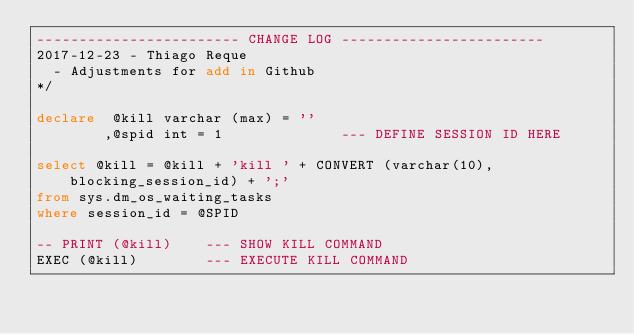Convert code to text. <code><loc_0><loc_0><loc_500><loc_500><_SQL_>------------------------ CHANGE LOG ------------------------
2017-12-23 - Thiago Reque
  - Adjustments for add in Github
*/

declare  @kill varchar (max) = ''
		,@spid int = 1 				--- DEFINE SESSION ID HERE

select @kill = @kill + 'kill ' + CONVERT (varchar(10), blocking_session_id) + ';' 
from sys.dm_os_waiting_tasks
where session_id = @SPID

-- PRINT (@kill)	--- SHOW KILL COMMAND
EXEC (@kill)		--- EXECUTE KILL COMMAND
</code> 